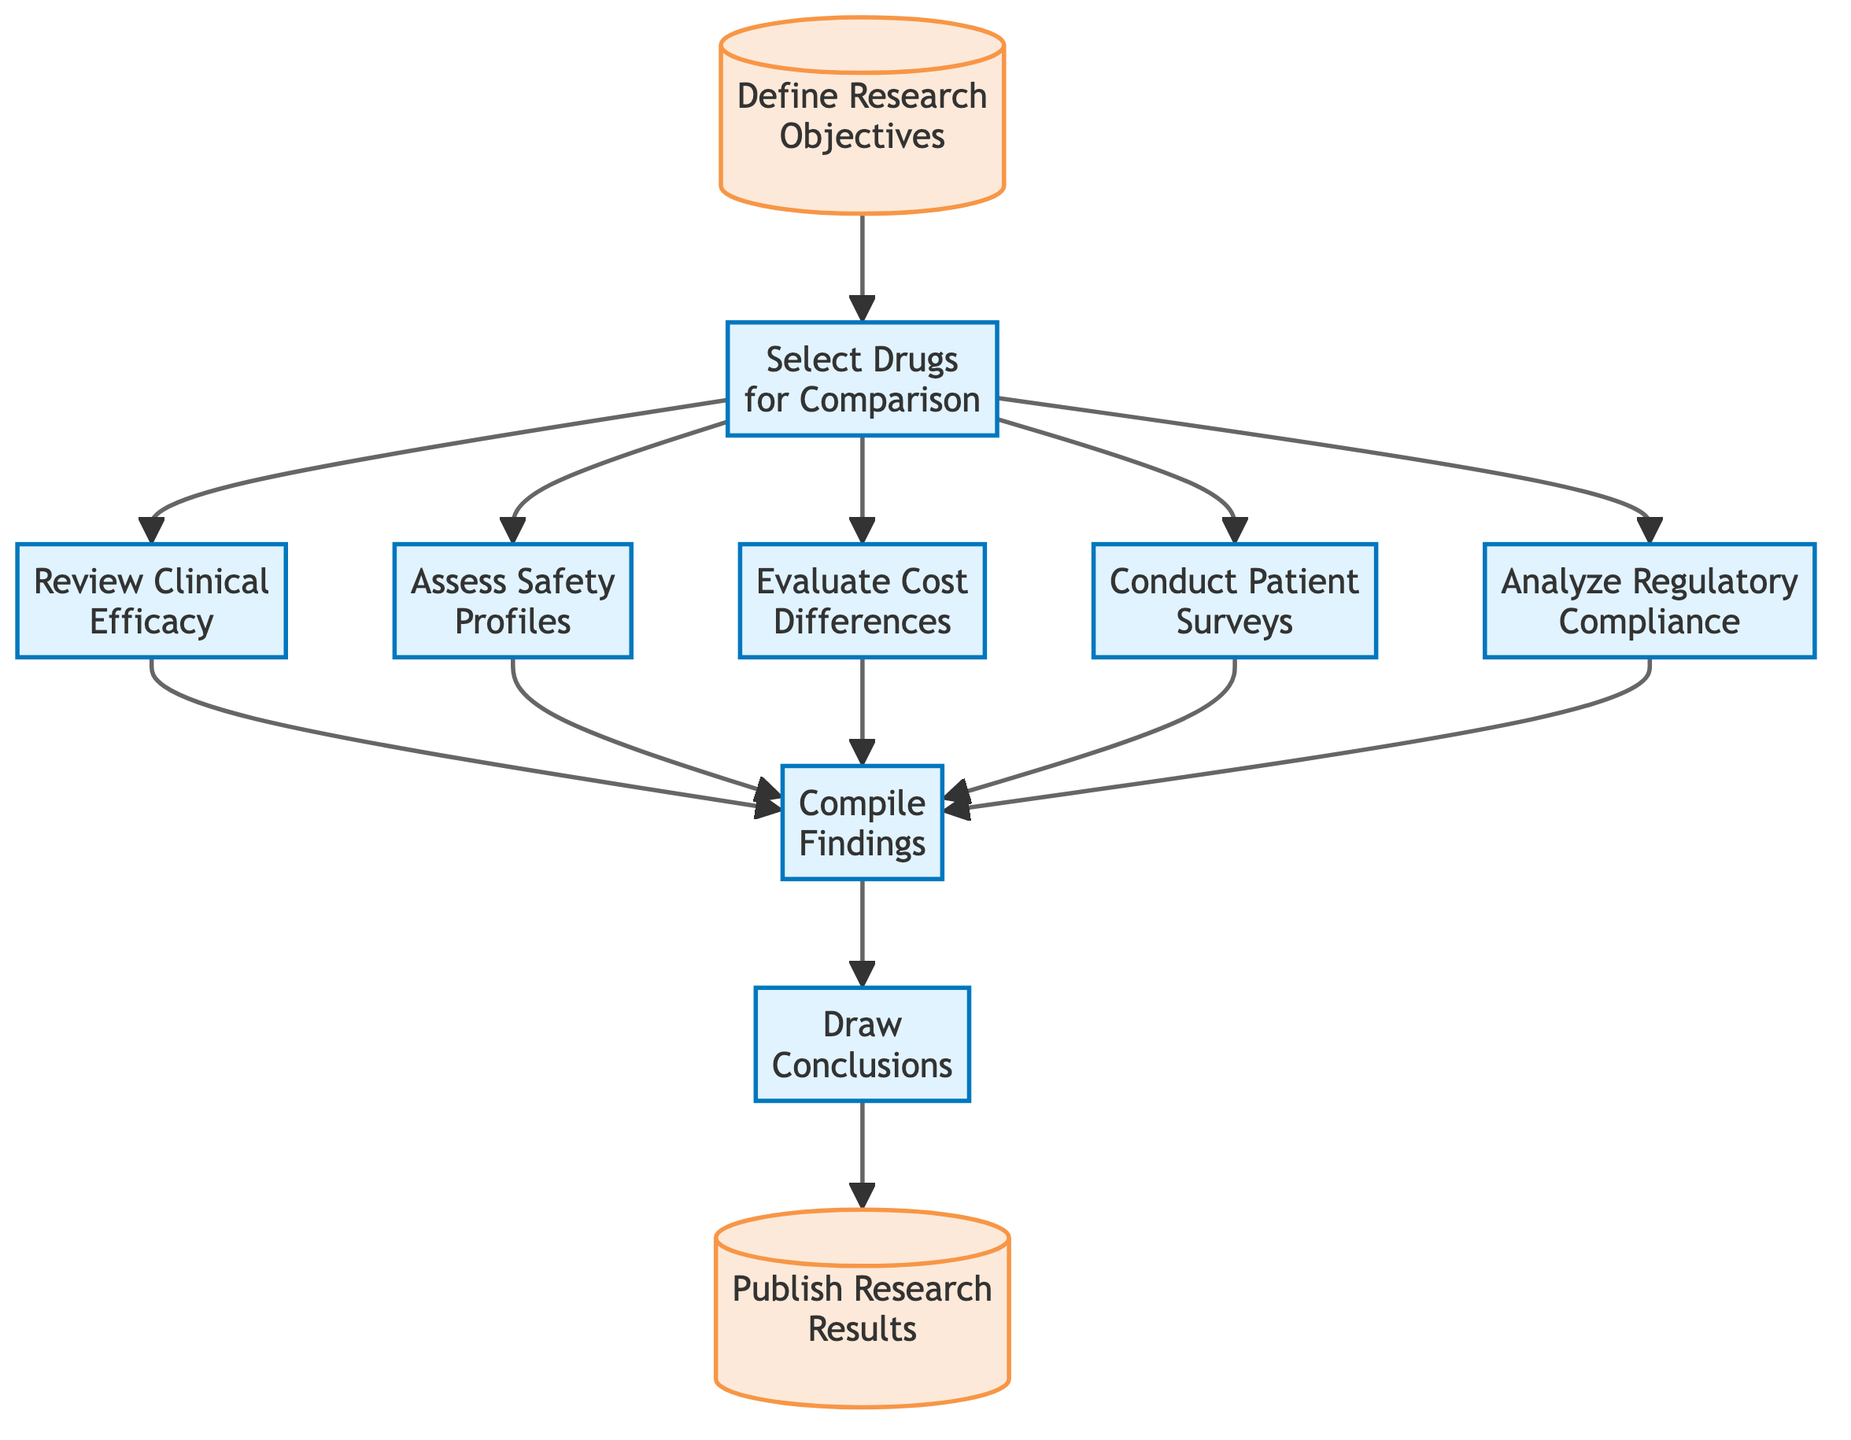What is the first step in the evaluation process? The diagram shows that the first step is "Define Research Objectives," indicating that establishing goals is the starting point of the process.
Answer: Define Research Objectives How many nodes are in the evaluation process flowchart? By counting the individual elements listed in the diagram, there are ten nodes representing different steps.
Answer: 10 What is evaluated after selecting drugs for comparison? According to the flowchart, after selecting drugs, the next steps are "Review Clinical Efficacy," "Assess Safety Profiles," "Evaluate Cost Differences," "Conduct Patient Surveys," and "Analyze Regulatory Compliance."
Answer: Review Clinical Efficacy, Assess Safety Profiles, Evaluate Cost Differences, Conduct Patient Surveys, Analyze Regulatory Compliance Which step comes before publishing research results? The diagram indicates that "Draw Conclusions" precedes "Publish Research Results," linking the synthesis of findings to the dissemination of results.
Answer: Draw Conclusions What are the final two steps in the evaluation process? Reviewing the flowchart, the last two steps outlined are "Draw Conclusions" followed by "Publish Research Results," indicating the conclusion leads directly to publication.
Answer: Draw Conclusions, Publish Research Results What type of compliance is analyzed in the evaluation process? The flowchart specifies that "Analyze Regulatory Compliance" is part of the evaluation process, signaling a focus on FDA approval and compliance aspects.
Answer: Regulatory Compliance Which step involves gathering patient feedback? According to the flowchart, "Conduct Patient Surveys" specifically addresses the gathering of patient experiences and feedback on the drug types being studied.
Answer: Conduct Patient Surveys What step follows the evaluation of safety profiles? The flowchart indicates that after "Assess Safety Profiles," the next step is to "Compile Findings," where data and insights from all evaluations are summarized.
Answer: Compile Findings How many evaluations directly lead to the compilation of findings? The diagram shows that five evaluations ("Review Clinical Efficacy," "Assess Safety Profiles," "Evaluate Cost Differences," "Conduct Patient Surveys," and "Analyze Regulatory Compliance") lead into the "Compile Findings" node, illustrating the integration of multiple evaluations.
Answer: 5 